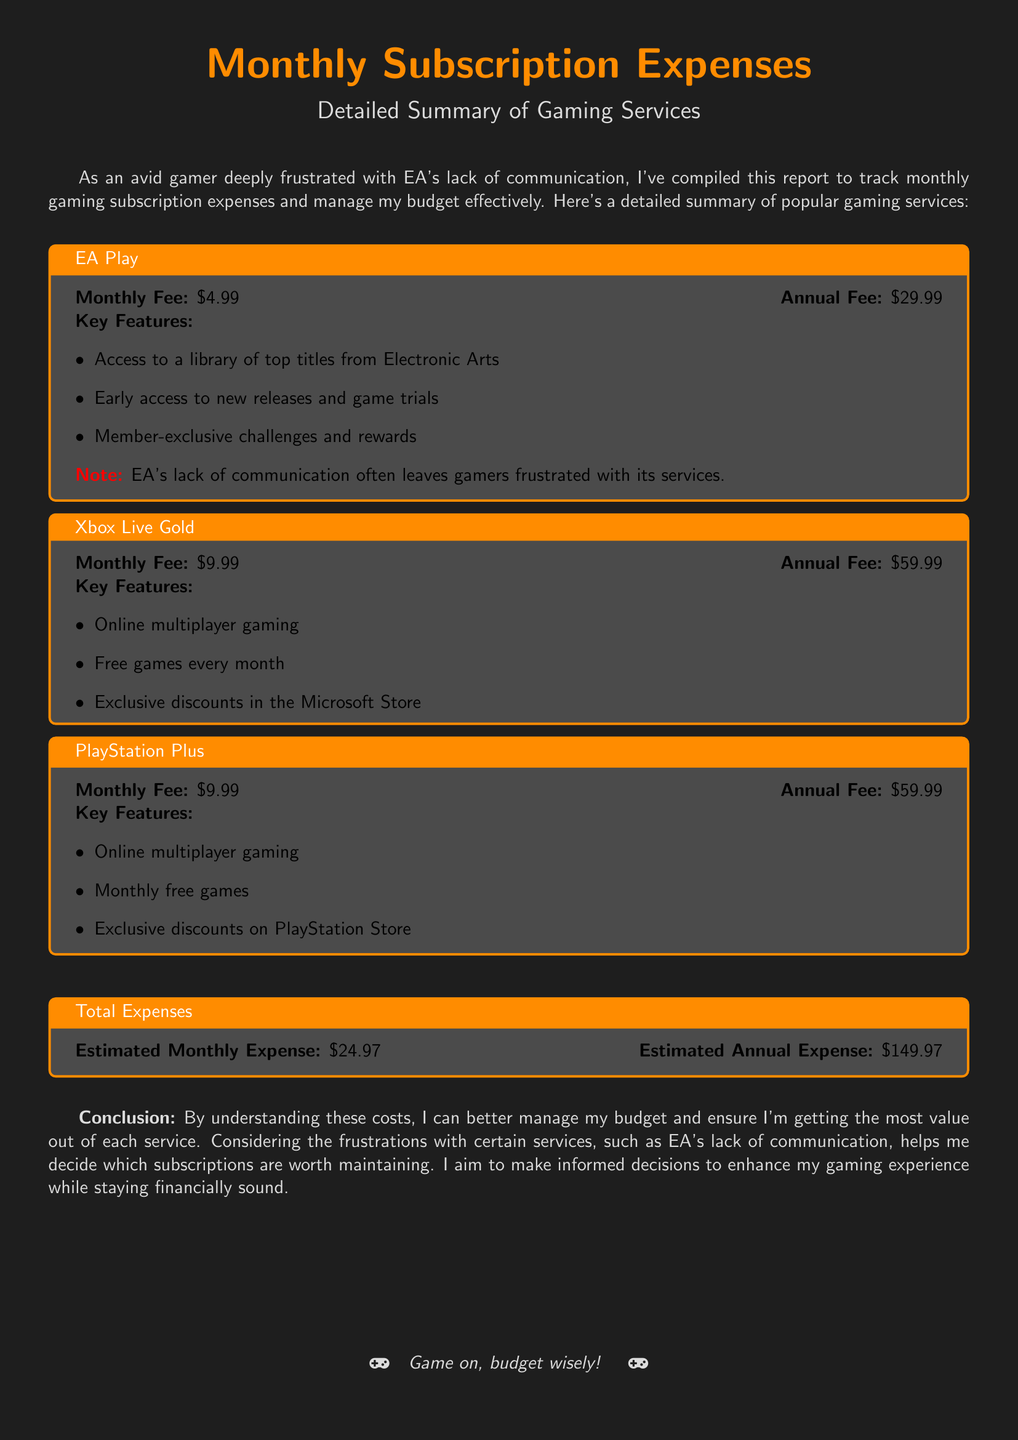what is the monthly fee for EA Play? The monthly fee for EA Play is listed in the document as $4.99.
Answer: $4.99 what features are included with Xbox Live Gold? The features of Xbox Live Gold are summarized in a bullet list, which includes online multiplayer gaming, free games every month, and exclusive discounts in the Microsoft Store.
Answer: Online multiplayer gaming, free games every month, exclusive discounts in the Microsoft Store what is the estimated monthly expense for all subscriptions combined? The estimated monthly expense is stated in the Total Expenses section as $24.97.
Answer: $24.97 how much does PlayStation Plus cost annually? The annual fee for PlayStation Plus is provided as $59.99 in the document.
Answer: $59.99 what specific frustration is mentioned regarding EA services? The document highlights EA's lack of communication as a specific frustration experienced by gamers.
Answer: EA's lack of communication which service provides early access to new releases? EA Play is specifically mentioned as providing early access to new releases and game trials.
Answer: EA Play what is the total annual expense for all subscriptions? The total annual expense is given as $149.97 in the Total Expenses section of the document.
Answer: $149.97 which two gaming services have the same monthly fee? Xbox Live Gold and PlayStation Plus both have a monthly fee of $9.99 as stated in the document.
Answer: Xbox Live Gold and PlayStation Plus what is the color used for the document's background? The background color specified for the document is a deep shade referred to as gamerbg, which is RGB 30,30,30.
Answer: RGB 30,30,30 